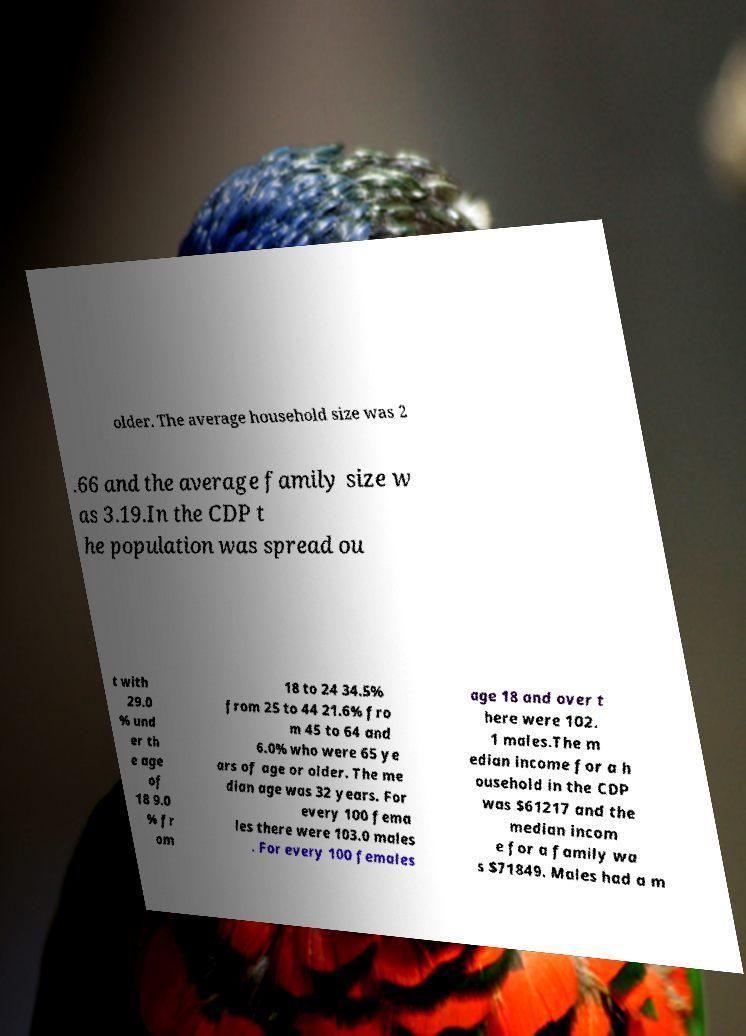What messages or text are displayed in this image? I need them in a readable, typed format. older. The average household size was 2 .66 and the average family size w as 3.19.In the CDP t he population was spread ou t with 29.0 % und er th e age of 18 9.0 % fr om 18 to 24 34.5% from 25 to 44 21.6% fro m 45 to 64 and 6.0% who were 65 ye ars of age or older. The me dian age was 32 years. For every 100 fema les there were 103.0 males . For every 100 females age 18 and over t here were 102. 1 males.The m edian income for a h ousehold in the CDP was $61217 and the median incom e for a family wa s $71849. Males had a m 